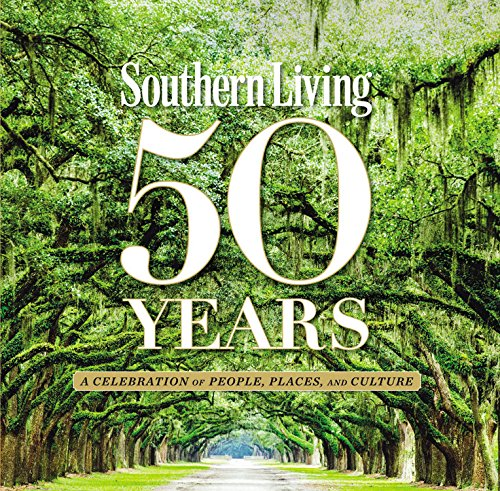Who is the author of this book?
Answer the question using a single word or phrase. The Editors of Southern Living Magazine What is the title of this book? Southern Living 50 Years: A Celebration of People, Places, and Culture What is the genre of this book? Cookbooks, Food & Wine Is this a recipe book? Yes Is this a motivational book? No 